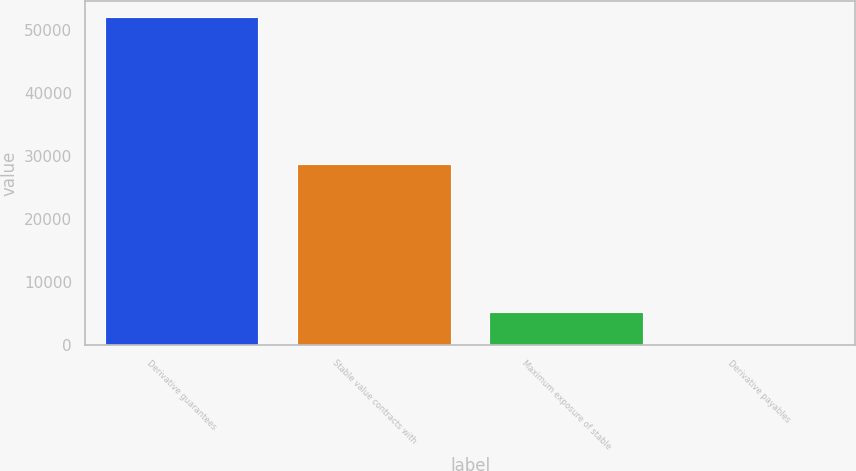Convert chart. <chart><loc_0><loc_0><loc_500><loc_500><bar_chart><fcel>Derivative guarantees<fcel>Stable value contracts with<fcel>Maximum exposure of stable<fcel>Derivative payables<nl><fcel>51966<fcel>28665<fcel>5283<fcel>96<nl></chart> 